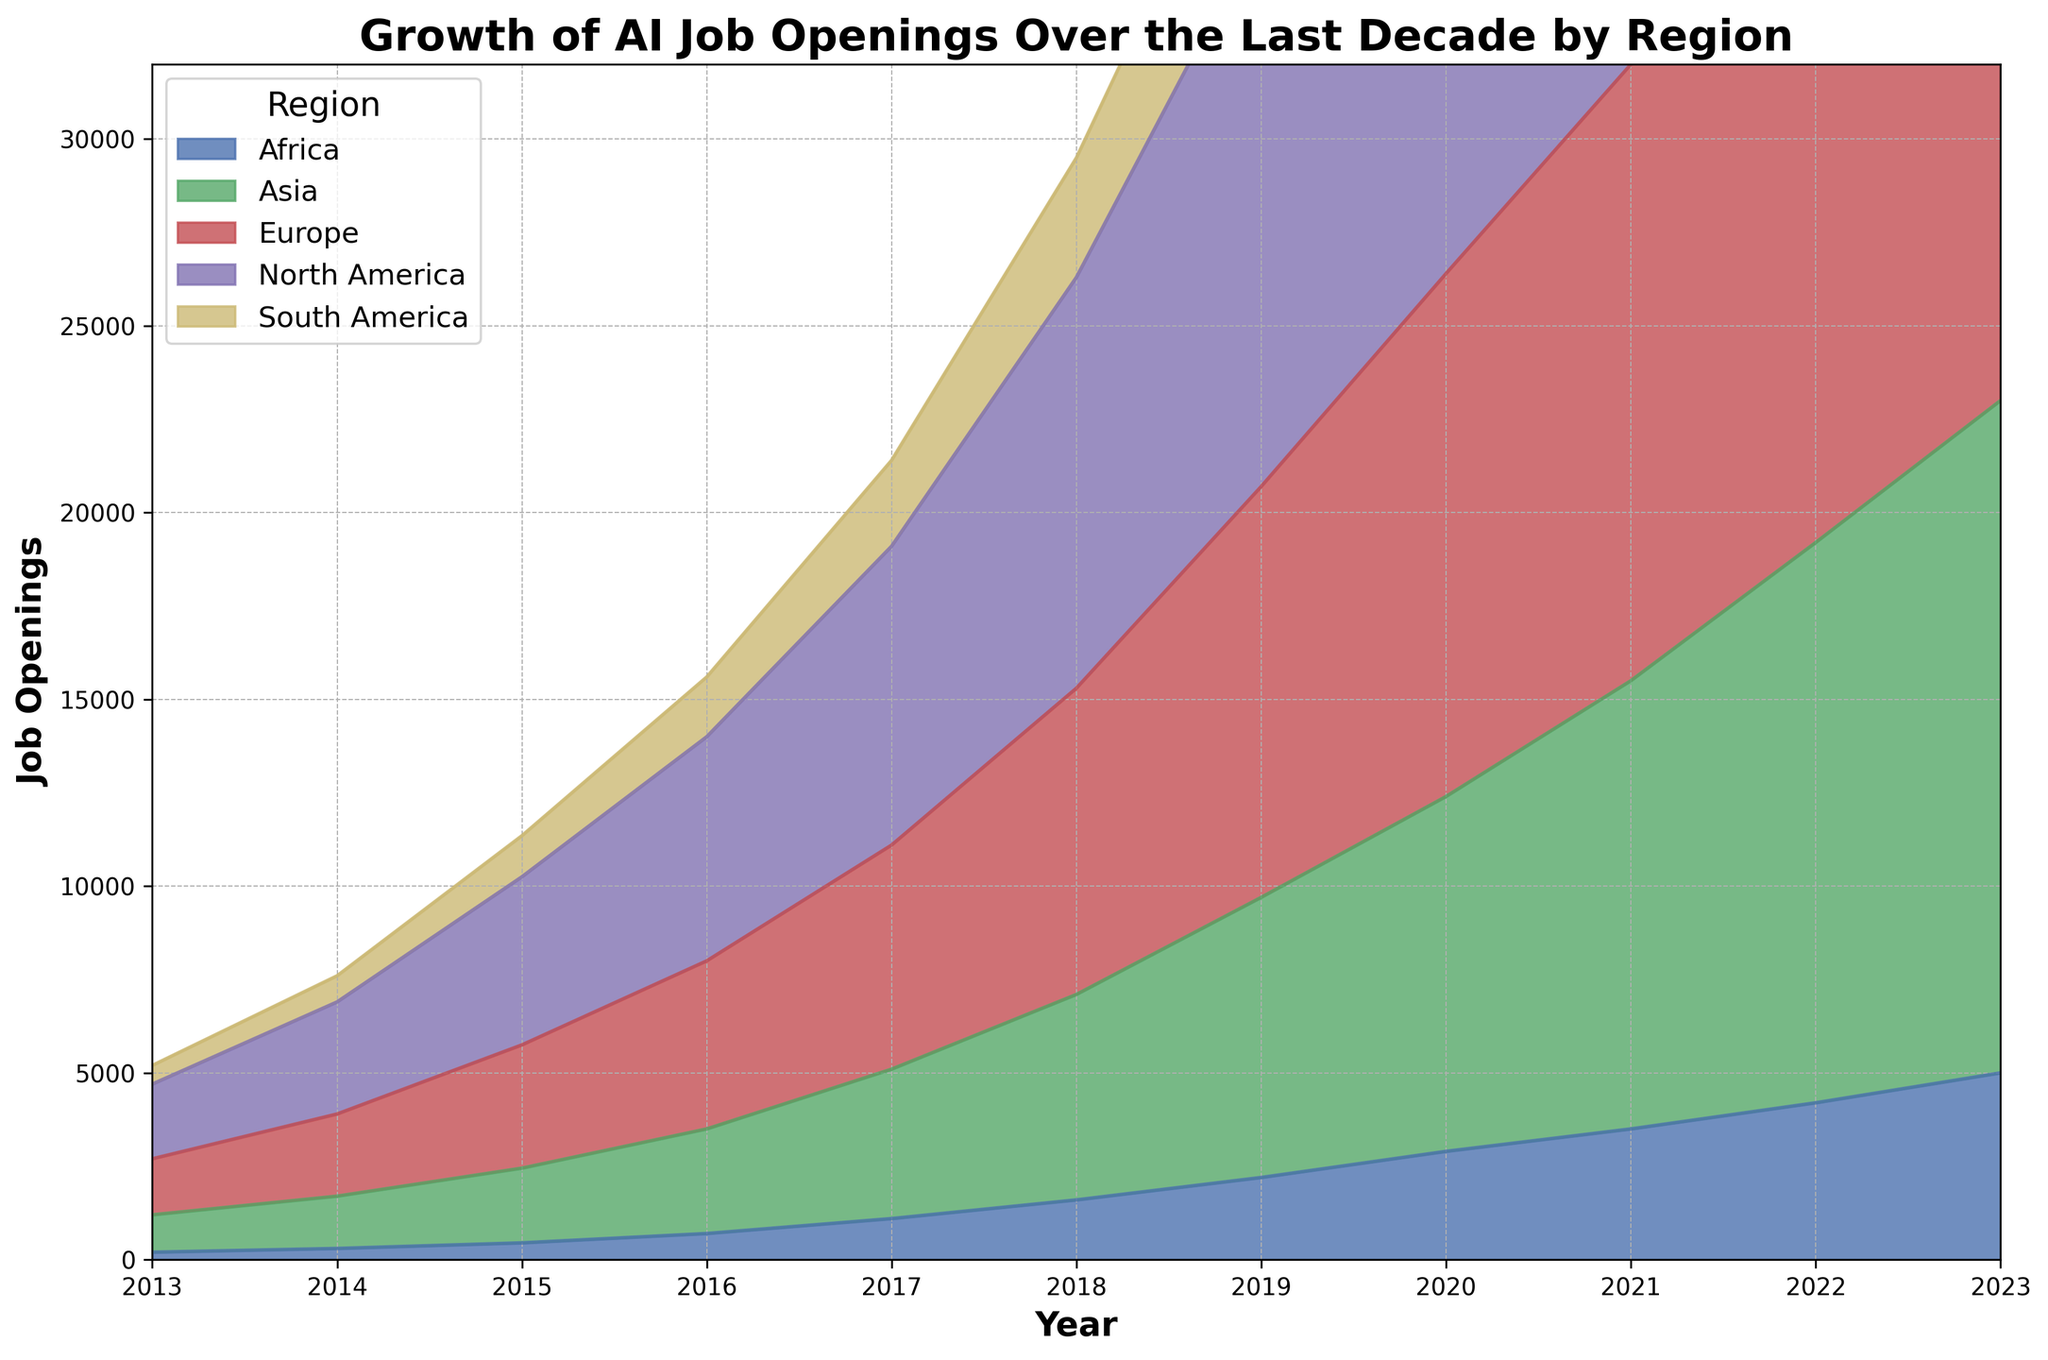How did the number of AI job openings in North America change from 2013 to 2023? To find the change in AI job openings in North America from 2013 to 2023, we subtract the number of job openings in 2013 from those in 2023. From the chart, in 2013, North America had 2000 openings and in 2023 had 30000 openings. The change is 30000 - 2000 = 28000.
Answer: 28000 Which region had the highest number of AI job openings in 2020 and how many? By visually inspecting the height of the areas representing different regions in 2020 on the chart, North America's area is the highest. The chart indicates that North America had 19000 AI job openings in that year.
Answer: North America, 19000 What is the approximate total number of AI job openings in all regions in 2017? To approximate the total number of AI job openings in all regions in 2017, sum up the number of job openings in each region in that year. From the chart: North America = 8000, Europe = 6000, Asia = 4000, South America = 2300, Africa = 1100. The total is 8000 + 6000 + 4000 + 2300 + 1100 = 21400.
Answer: 21400 Which region shows the fastest growth in AI job openings from 2013 to 2023? By comparing the slopes of the regions' areas over time, North America shows the steepest increase from 2000 in 2013 to 30000 in 2023, indicating the fastest growth.
Answer: North America Between which consecutive years did Europe see the largest increase in AI job openings? By how much? By examining the height differences of Europe’s area between consecutive years, the largest increase appears between 2017 and 2018. From the chart, job openings increased from 6000 to 8200, an increase of 8200 - 6000 = 2200.
Answer: 2017 to 2018, 2200 How does the number of AI job openings in Asia in 2023 compare to that of South America in the same year? Visually comparing the height of the areas in 2023 for Asia and South America, Asia’s area is significantly higher. According to the chart, Asia had 18000 openings while South America had 9500.
Answer: Asia had more openings What is the average number of AI job openings per year in Africa from 2013 to 2023? To compute the average, sum the number of AI job openings in Africa for each year from 2013 to 2023 and divide by the number of years (11 years). Sum of job openings: 200 + 300 + 450 + 700 + 1100 + 1600 + 2200 + 2900 + 3500 + 4200 + 5000 = 22150. Average = 22150/11 ≈ 2014.
Answer: 2014 How did the job openings in Europe in 2023 compare to the overall job openings in South America for the span 2013 to 2023? First, find the total job openings in South America from 2013 to 2023. Sum the yearly openings: 500 + 700 + 1100 + 1600 + 2300 + 3200 + 4300 + 5600 + 6800 + 8100 + 9500 = 44700. Europe's job openings in 2023 are 22000. 22000 < 44700.
Answer: Less than 